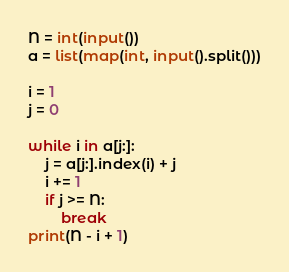<code> <loc_0><loc_0><loc_500><loc_500><_Python_>N = int(input())
a = list(map(int, input().split()))

i = 1
j = 0

while i in a[j:]:
    j = a[j:].index(i) + j
    i += 1
    if j >= N:
        break
print(N - i + 1)
</code> 